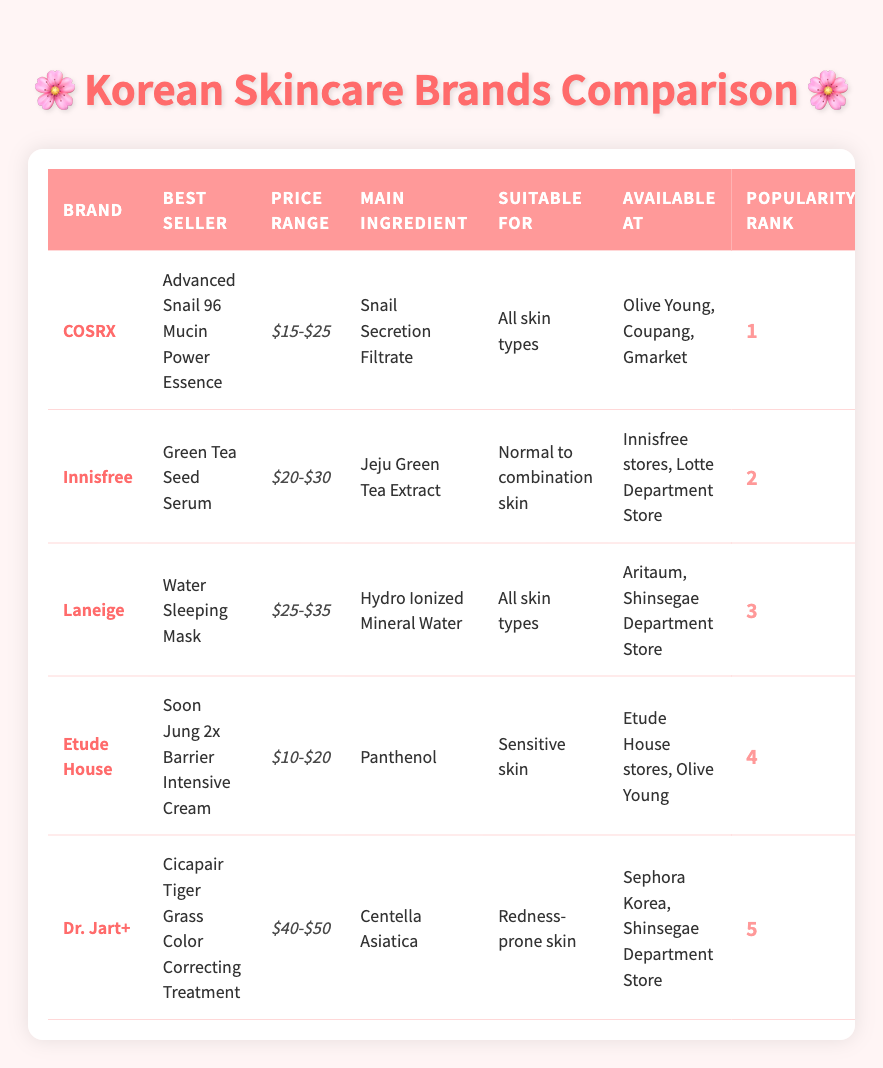What is the best-selling product of COSRX? According to the table, the brand COSRX has its best-selling product listed as "Advanced Snail 96 Mucin Power Essence."
Answer: Advanced Snail 96 Mucin Power Essence Which brand has a best-seller suitable for sensitive skin? The table indicates that Etude House has a best-selling product, "Soon Jung 2x Barrier Intensive Cream," that is suitable for sensitive skin.
Answer: Etude House What is the price range of Laneige's best-selling product? The price range for Laneige's best-selling product, "Water Sleeping Mask," is stated in the table as "$25-$35."
Answer: $25-$35 Is the main ingredient of Dr. Jart+'s product Centella Asiatica? Referring to the table, Dr. Jart+'s best-selling product has Centella Asiatica as its main ingredient, making the statement true.
Answer: Yes Which brand has the highest popularity rank and what is its price range? The brand with the highest popularity rank is COSRX at rank 1, with a price range listed as "$15-$25."
Answer: COSRX, $15-$25 What is the average price range of the top three best-selling products? The price ranges for the top three products are $15-$25, $20-$30, and $25-$35, respectively. First, I convert these ranges into numeric averages: (20 + 25 + 30) / 3 = 25 (averaging the midpoints). Thus the average price range is approximately $20-$30.
Answer: $20-$30 Are any of the best-selling products suitable for all skin types? By examining the table, both COSRX and Laneige have best-selling products suitable for all skin types. Therefore, the statement is true.
Answer: Yes Which brand has the lowest priced best-seller and what is it? Scanning the table, the best-seller with the lowest price range is from Etude House, which is "Soon Jung 2x Barrier Intensive Cream" with a price range of "$10-$20."
Answer: Etude House, Soon Jung 2x Barrier Intensive Cream How many brands have products suitable for redness-prone skin? The table shows only one brand, Dr. Jart+, with a best-seller suitable for redness-prone skin. So, there is only one brand.
Answer: 1 